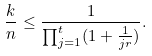<formula> <loc_0><loc_0><loc_500><loc_500>\frac { k } { n } \leq \frac { 1 } { \prod _ { j = 1 } ^ { t } ( 1 + \frac { 1 } { j r } ) } .</formula> 